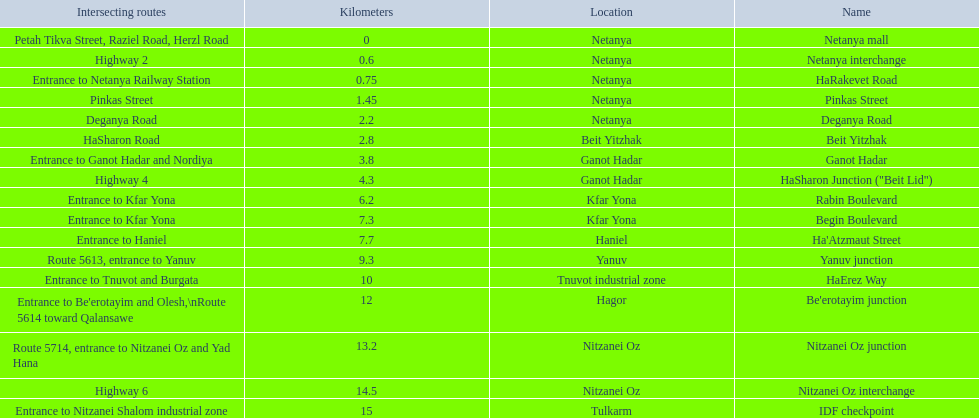Which section is longest?? IDF checkpoint. 